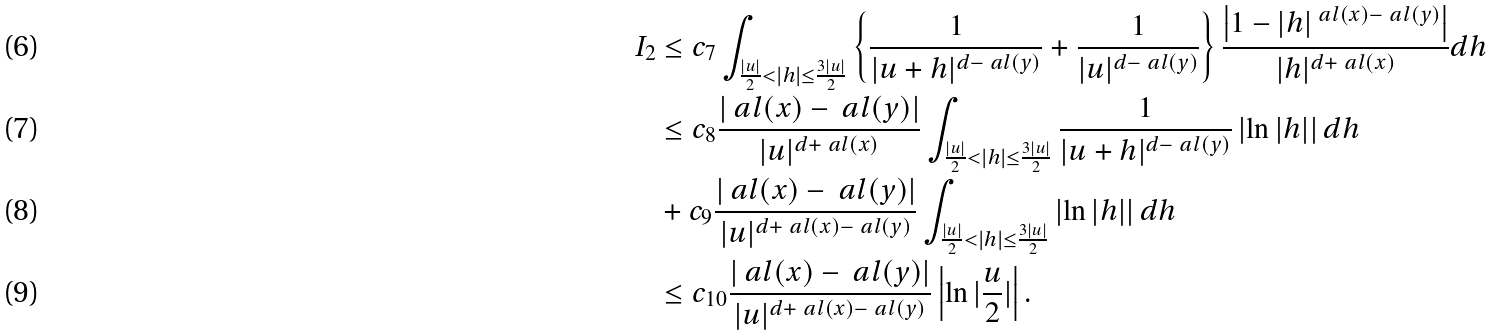<formula> <loc_0><loc_0><loc_500><loc_500>I _ { 2 } & \leq c _ { 7 } \int _ { \frac { | u | } { 2 } < | h | \leq \frac { 3 | u | } { 2 } } \left \{ \frac { 1 } { | u + h | ^ { d - \ a l ( y ) } } + \frac { 1 } { | u | ^ { d - \ a l ( y ) } } \right \} \frac { \left | 1 - | h | ^ { \ a l ( x ) - \ a l ( y ) } \right | } { | h | ^ { d + \ a l ( x ) } } d h \\ & \leq c _ { 8 } \frac { | \ a l ( x ) - \ a l ( y ) | } { | u | ^ { d + \ a l ( x ) } } \int _ { \frac { | u | } { 2 } < | h | \leq \frac { 3 | u | } { 2 } } \frac { 1 } { | u + h | ^ { d - \ a l ( y ) } } \left | \ln | h | \right | d h \\ & + c _ { 9 } \frac { | \ a l ( x ) - \ a l ( y ) | } { | u | ^ { d + \ a l ( x ) - \ a l ( y ) } } \int _ { \frac { | u | } { 2 } < | h | \leq \frac { 3 | u | } { 2 } } \left | \ln | h | \right | d h \\ & \leq c _ { 1 0 } \frac { | \ a l ( x ) - \ a l ( y ) | } { | u | ^ { d + \ a l ( x ) - \ a l ( y ) } } \left | \ln | \frac { u } { 2 } | \right | .</formula> 